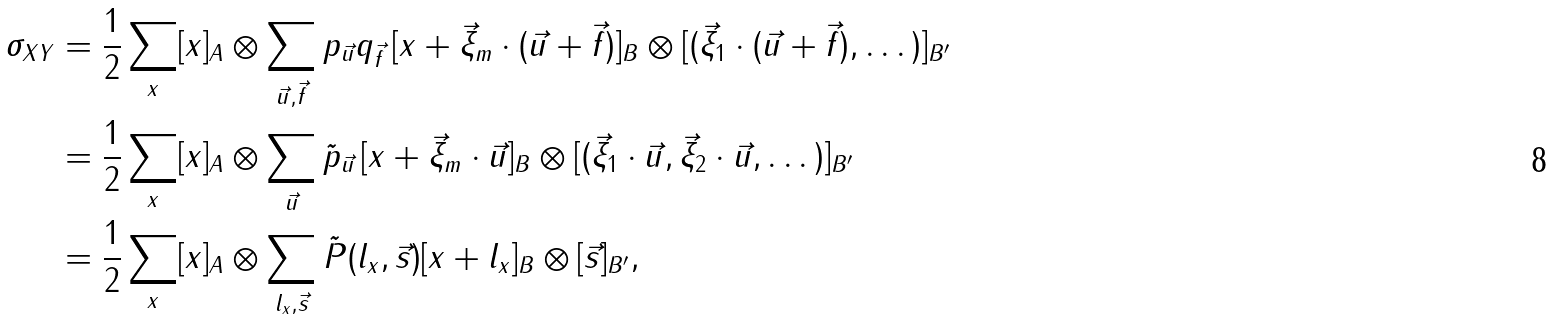<formula> <loc_0><loc_0><loc_500><loc_500>\sigma _ { X Y } & = \frac { 1 } { 2 } \sum _ { x } [ x ] _ { A } \otimes \sum _ { \vec { u } , \vec { f } } p _ { \vec { u } } q _ { \vec { f } } \, [ x + \vec { \xi } _ { m } \cdot ( \vec { u } + \vec { f } ) ] _ { B } \otimes [ ( \vec { \xi } _ { 1 } \cdot ( \vec { u } + \vec { f } ) , \dots ) ] _ { B ^ { \prime } } \\ & = \frac { 1 } { 2 } \sum _ { x } [ x ] _ { A } \otimes \sum _ { \vec { u } } \tilde { p } _ { \vec { u } } \, [ x + \vec { \xi } _ { m } \cdot \vec { u } ] _ { B } \otimes [ ( \vec { \xi } _ { 1 } \cdot \vec { u } , \vec { \xi } _ { 2 } \cdot \vec { u } , \dots ) ] _ { B ^ { \prime } } \\ & = \frac { 1 } { 2 } \sum _ { x } [ x ] _ { A } \otimes \sum _ { l _ { x } , \vec { s } } \tilde { P } ( l _ { x } , \vec { s } ) [ x + l _ { x } ] _ { B } \otimes [ \vec { s } ] _ { B ^ { \prime } } ,</formula> 